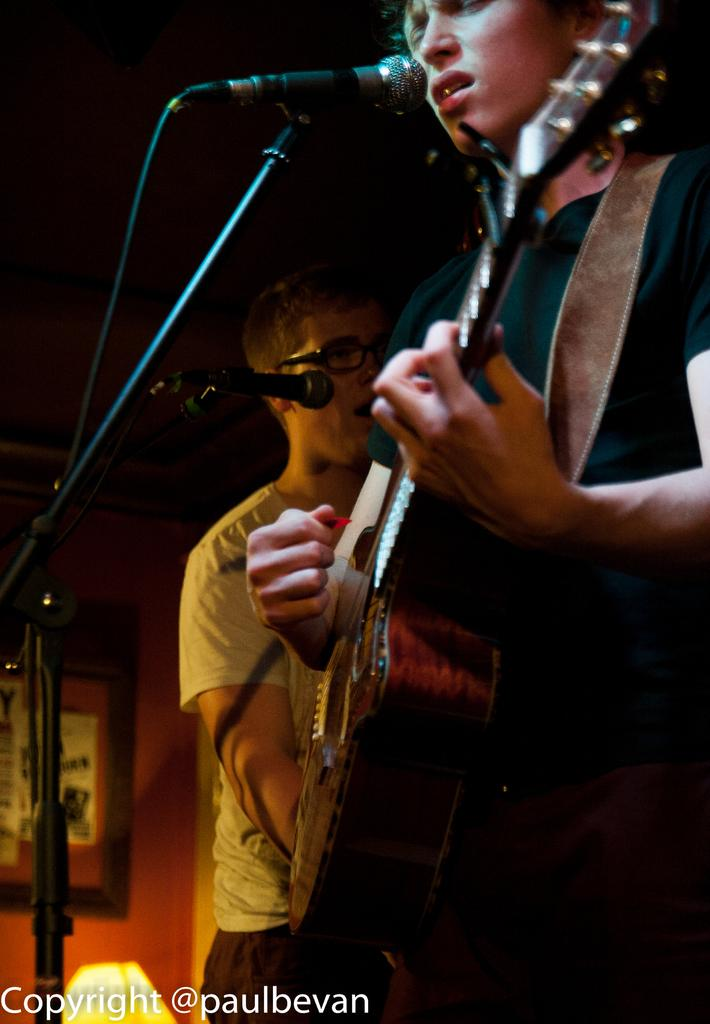What is the person in the image holding? The person in the image is holding a guitar. Can you describe the other person in the image? There is another person standing beside the person with the guitar. What objects are present in front of the two people? Microphones are present in front of the two people. What type of rake is being used to create waves in the background of the image? There is no rake or waves present in the image; it features two people and microphones. Can you tell me how many calculators are visible on the table in the image? There are no calculators visible in the image. 